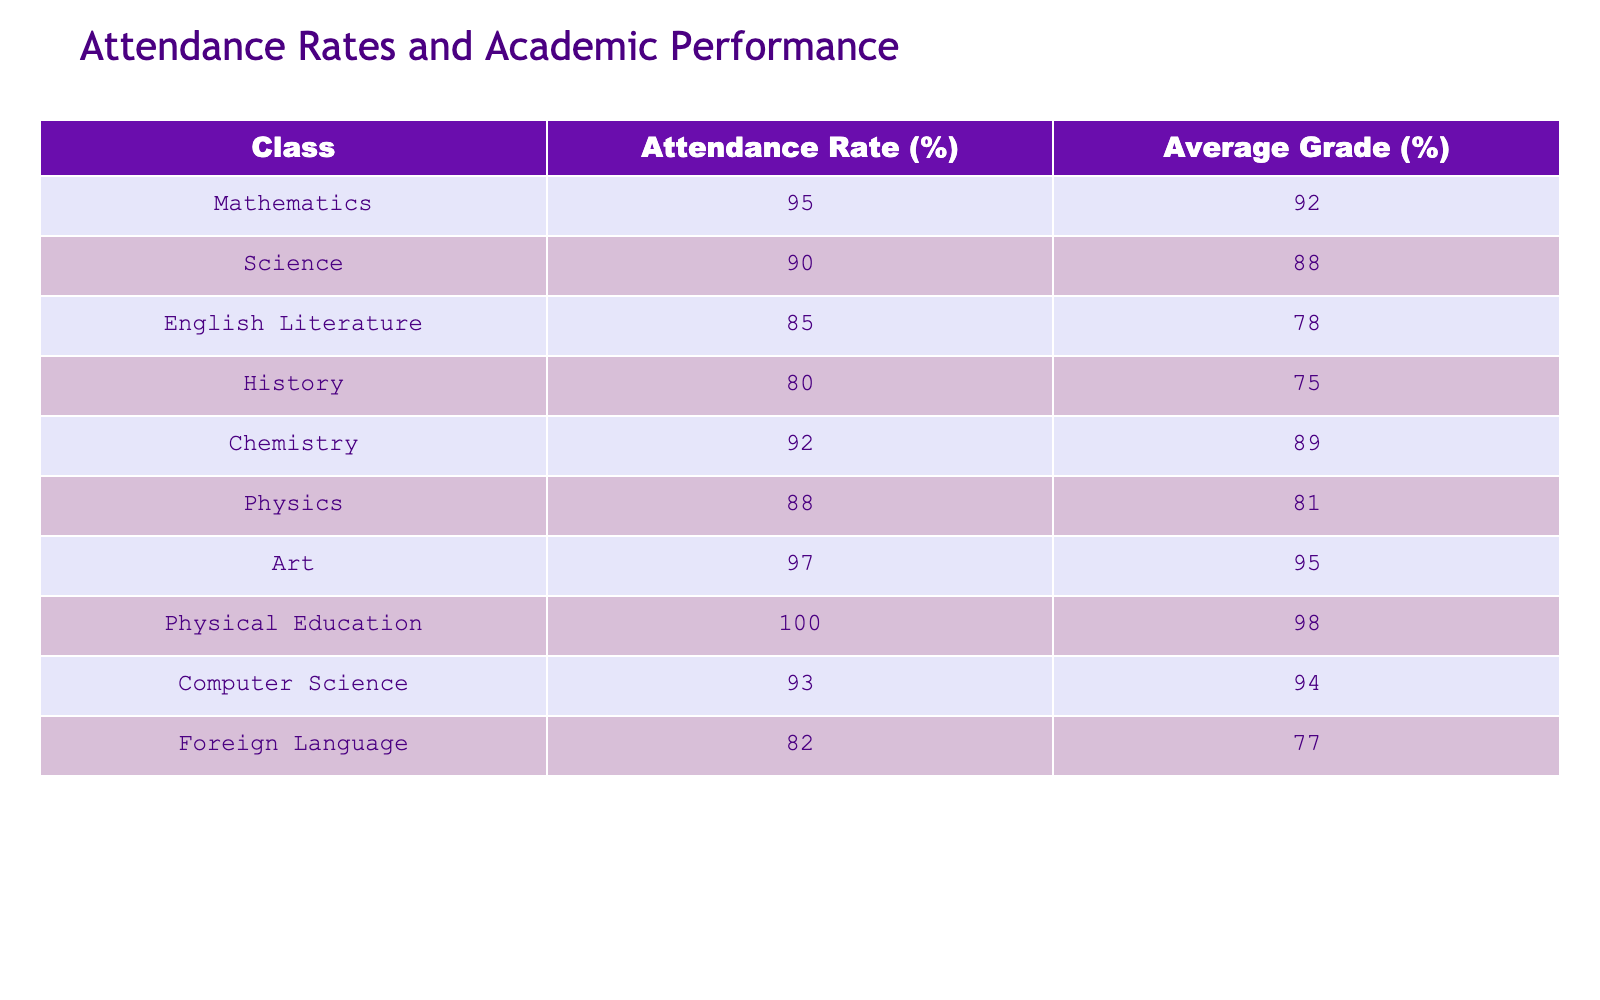What is the attendance rate for Physical Education? The attendance rate is directly listed in the table under the corresponding class column. For Physical Education, the Attendance Rate is 100%.
Answer: 100% Which subject has the highest average grade? The average grades for all subjects are listed in the column titled Average Grade. Scanning through the entries, the highest average grade is 98%, which belongs to Physical Education.
Answer: 98% Does the Chemistry class have a lower attendance rate than English Literature? We need to compare the attendance rates: Chemistry is 92% and English Literature is 85%. Since 92% is greater than 85%, the statement is false.
Answer: No What is the difference in attendance rates between Art and Foreign Language classes? We check the attendance rates: Art has 97% and Foreign Language has 82%. The difference is 97 - 82 = 15%.
Answer: 15% What is the average attendance rate across all classes? To get the average, we need to add all the attendance rates together: 95 + 90 + 85 + 80 + 92 + 88 + 97 + 100 + 93 + 82 = 910. Since there are 10 classes, we divide by 10: 910/10 = 91%.
Answer: 91% Is there any class where the attendance rate is below 80%? We need to look for any attendance rates below 80%. The lowest attendance rate in the table is 80% for History, so no class is below that.
Answer: No Which class has the lowest average grade? The average grades for all classes are compared: the lowest average grade listed is 75%, associated with History.
Answer: 75% If we combine the attendance rates of Mathematics and Science, what is their total? We find the attendance rates for Mathematics (95%) and Science (90%), then add them together: 95 + 90 = 185%.
Answer: 185% 